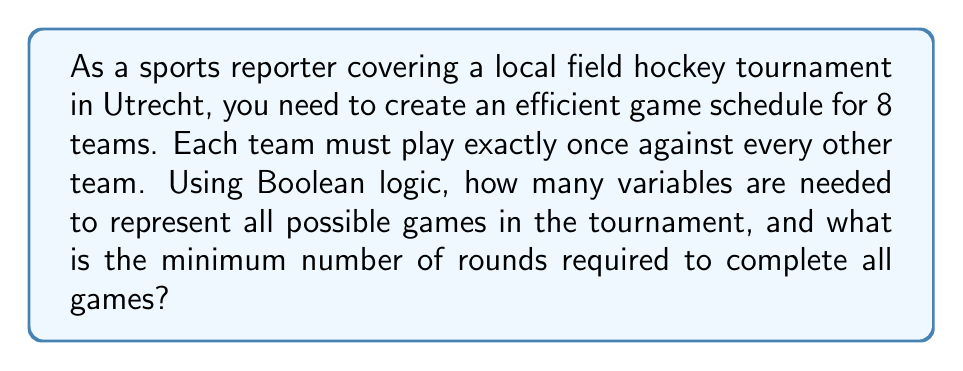Teach me how to tackle this problem. Let's approach this step-by-step:

1) First, we need to determine the total number of games. With 8 teams, each team plays 7 other teams. The total number of games is:

   $$ \frac{8 \times 7}{2} = 28 $$

   We divide by 2 because each game is counted twice in the 8 × 7 calculation.

2) To represent each game as a Boolean variable, we need 28 variables. Let's call them $g_1, g_2, ..., g_{28}$.

3) Now, for the minimum number of rounds:
   - In each round, one team can play only one game.
   - With 8 teams, we can have 4 games per round (pairing all 8 teams).
   - We need to fit 28 games into as few rounds as possible.

4) The minimum number of rounds is calculated by:

   $$ \left\lceil\frac{\text{Total games}}{\text{Games per round}}\right\rceil = \left\lceil\frac{28}{4}\right\rceil = 7 $$

   Where $\lceil \cdot \rceil$ represents the ceiling function.

5) To verify this is possible, we can use the fact that in a complete graph with an even number of vertices (teams in this case), there exists a 1-factorization. This means we can indeed schedule all games in 7 rounds.
Answer: 28 variables, 7 rounds 